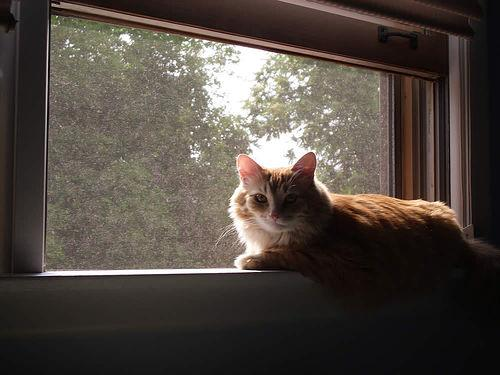Question: why is the cat on the window?
Choices:
A. Looking outside.
B. It's warm.
C. Sleeping in the sun.
D. Watching the birds.
Answer with the letter. Answer: B Question: what animal is pictured?
Choices:
A. A dog.
B. A bird.
C. A snake.
D. A cat.
Answer with the letter. Answer: D 